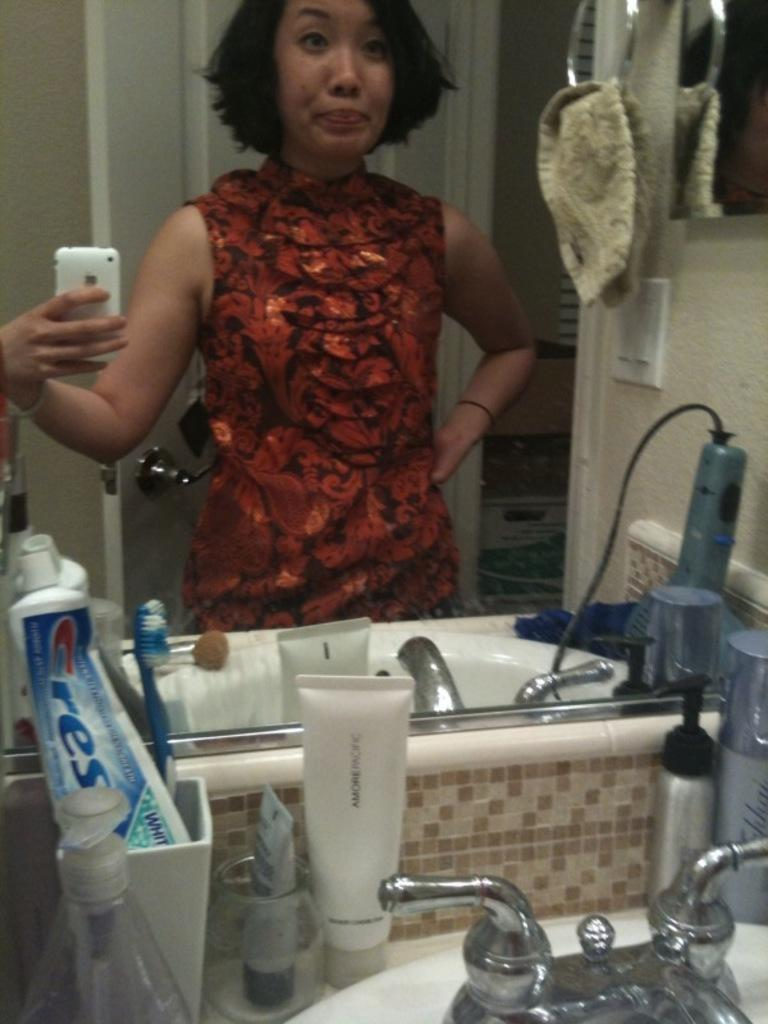Provide a one-sentence caption for the provided image. Woman taking a picture in a bathroom with a Crest toothpaste. 